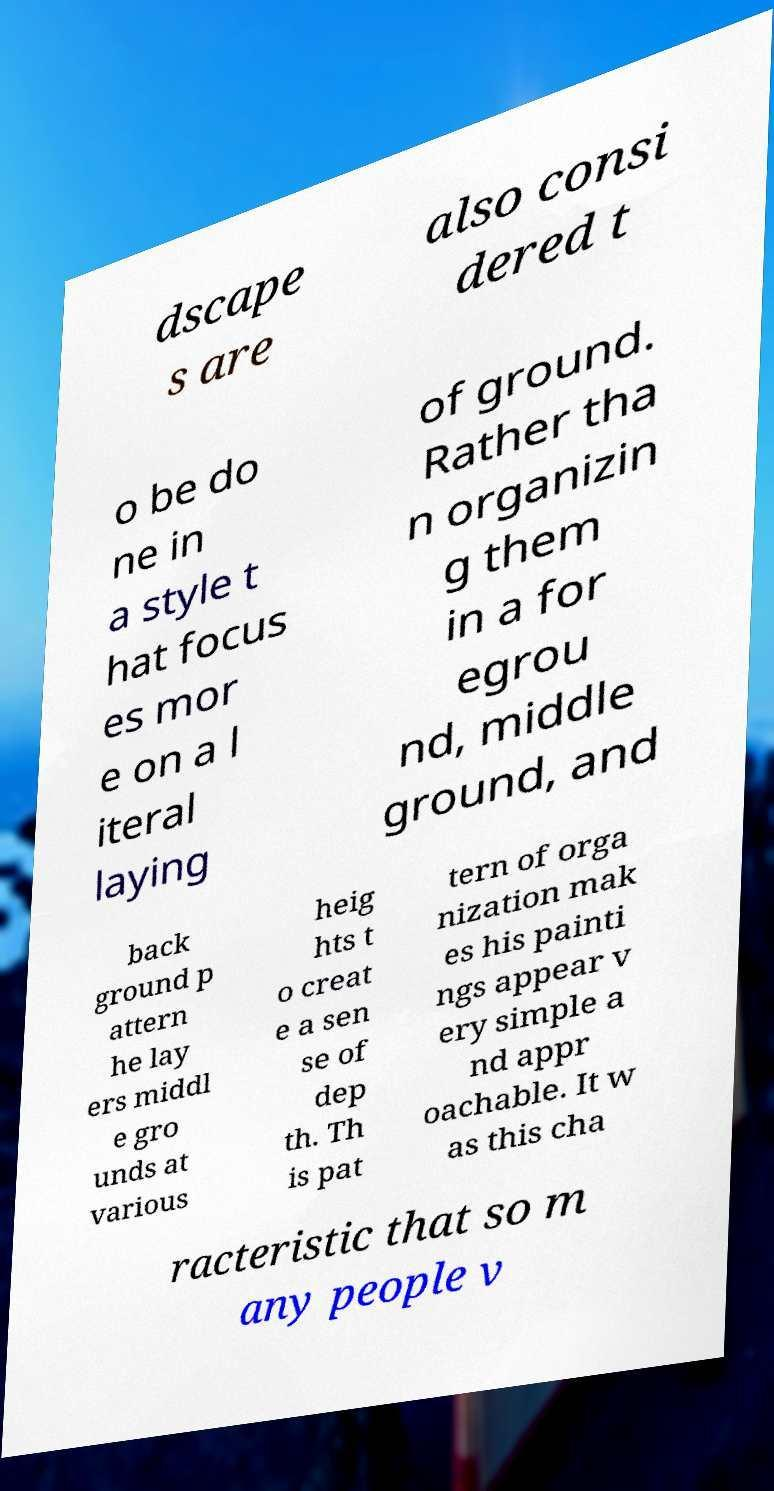Can you read and provide the text displayed in the image?This photo seems to have some interesting text. Can you extract and type it out for me? dscape s are also consi dered t o be do ne in a style t hat focus es mor e on a l iteral laying of ground. Rather tha n organizin g them in a for egrou nd, middle ground, and back ground p attern he lay ers middl e gro unds at various heig hts t o creat e a sen se of dep th. Th is pat tern of orga nization mak es his painti ngs appear v ery simple a nd appr oachable. It w as this cha racteristic that so m any people v 